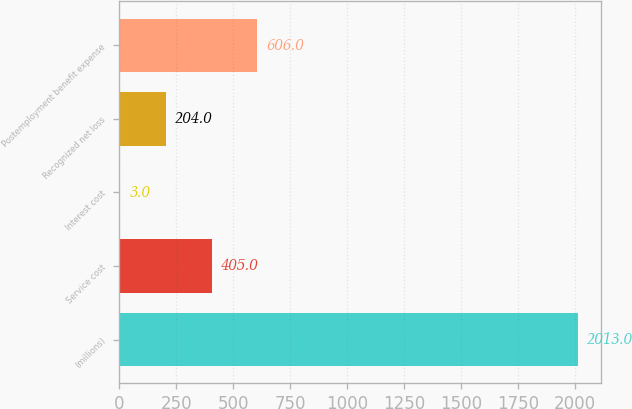<chart> <loc_0><loc_0><loc_500><loc_500><bar_chart><fcel>(millions)<fcel>Service cost<fcel>Interest cost<fcel>Recognized net loss<fcel>Postemployment benefit expense<nl><fcel>2013<fcel>405<fcel>3<fcel>204<fcel>606<nl></chart> 